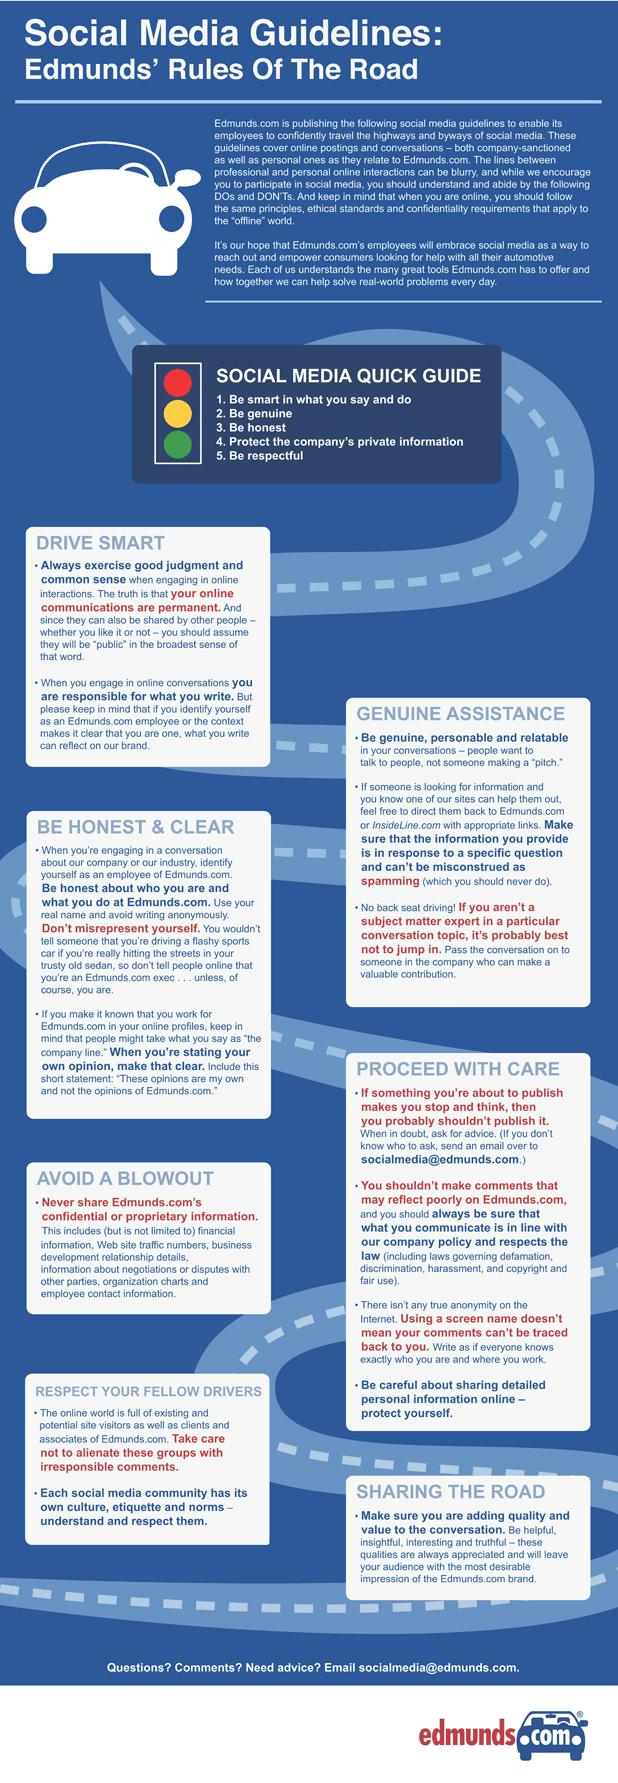List a handful of essential elements in this visual. When communicating with someone who is seeking help, it is important to keep in mind the need to be genuine, personable, and relatable in order to build a trusting and supportive relationship. The color of the first light in a traffic signal, typically green, yellow, red, and orange, is red. There are three points listed under the heading "Genuine Assistance". 